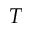Convert formula to latex. <formula><loc_0><loc_0><loc_500><loc_500>T</formula> 